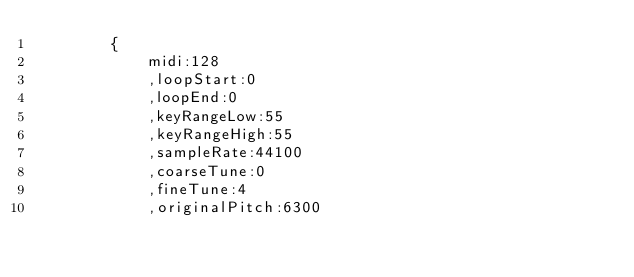<code> <loc_0><loc_0><loc_500><loc_500><_JavaScript_>		{
			midi:128
			,loopStart:0
			,loopEnd:0
			,keyRangeLow:55
			,keyRangeHigh:55
			,sampleRate:44100
			,coarseTune:0
			,fineTune:4
			,originalPitch:6300</code> 